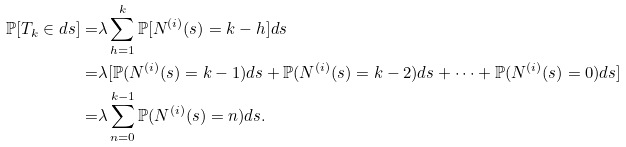<formula> <loc_0><loc_0><loc_500><loc_500>\mathbb { P } [ T _ { k } \in d s ] = & \lambda \sum _ { h = 1 } ^ { k } \mathbb { P } [ N ^ { ( i ) } ( s ) = k - h ] d s \\ = & \lambda [ \mathbb { P } ( N ^ { ( i ) } ( s ) = k - 1 ) d s + \mathbb { P } ( N ^ { ( i ) } ( s ) = k - 2 ) d s + \dots + \mathbb { P } ( N ^ { ( i ) } ( s ) = 0 ) d s ] \\ = & \lambda \sum _ { n = 0 } ^ { k - 1 } \mathbb { P } ( N ^ { ( i ) } ( s ) = n ) d s .</formula> 